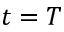Convert formula to latex. <formula><loc_0><loc_0><loc_500><loc_500>t = T</formula> 